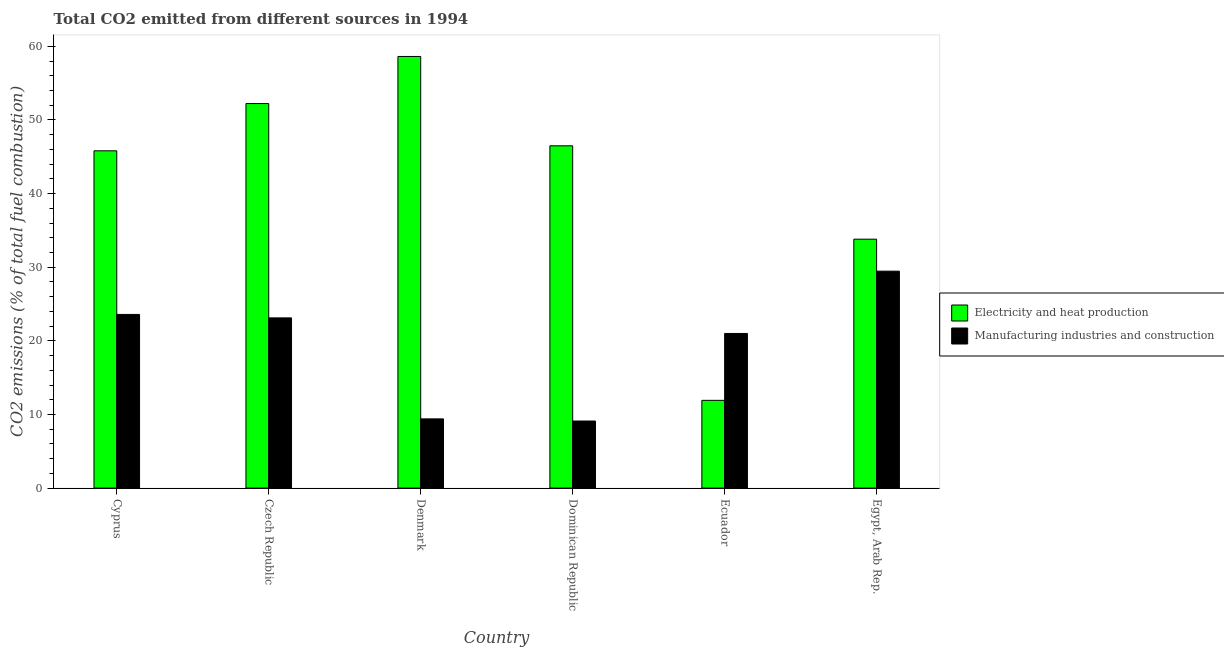How many groups of bars are there?
Your answer should be very brief. 6. Are the number of bars per tick equal to the number of legend labels?
Your response must be concise. Yes. Are the number of bars on each tick of the X-axis equal?
Your response must be concise. Yes. What is the label of the 3rd group of bars from the left?
Your answer should be very brief. Denmark. What is the co2 emissions due to electricity and heat production in Czech Republic?
Give a very brief answer. 52.23. Across all countries, what is the maximum co2 emissions due to electricity and heat production?
Offer a terse response. 58.62. Across all countries, what is the minimum co2 emissions due to electricity and heat production?
Your answer should be compact. 11.92. In which country was the co2 emissions due to electricity and heat production minimum?
Ensure brevity in your answer.  Ecuador. What is the total co2 emissions due to electricity and heat production in the graph?
Offer a terse response. 248.87. What is the difference between the co2 emissions due to electricity and heat production in Czech Republic and that in Denmark?
Your response must be concise. -6.4. What is the difference between the co2 emissions due to electricity and heat production in Egypt, Arab Rep. and the co2 emissions due to manufacturing industries in Dominican Republic?
Offer a very short reply. 24.7. What is the average co2 emissions due to manufacturing industries per country?
Offer a very short reply. 19.28. What is the difference between the co2 emissions due to manufacturing industries and co2 emissions due to electricity and heat production in Egypt, Arab Rep.?
Give a very brief answer. -4.34. In how many countries, is the co2 emissions due to electricity and heat production greater than 34 %?
Ensure brevity in your answer.  4. What is the ratio of the co2 emissions due to manufacturing industries in Cyprus to that in Denmark?
Your response must be concise. 2.51. Is the difference between the co2 emissions due to manufacturing industries in Cyprus and Ecuador greater than the difference between the co2 emissions due to electricity and heat production in Cyprus and Ecuador?
Ensure brevity in your answer.  No. What is the difference between the highest and the second highest co2 emissions due to manufacturing industries?
Your answer should be very brief. 5.87. What is the difference between the highest and the lowest co2 emissions due to manufacturing industries?
Give a very brief answer. 20.35. What does the 2nd bar from the left in Cyprus represents?
Your answer should be very brief. Manufacturing industries and construction. What does the 1st bar from the right in Egypt, Arab Rep. represents?
Offer a very short reply. Manufacturing industries and construction. How many bars are there?
Make the answer very short. 12. Are all the bars in the graph horizontal?
Your response must be concise. No. How many countries are there in the graph?
Offer a terse response. 6. Where does the legend appear in the graph?
Your answer should be very brief. Center right. What is the title of the graph?
Offer a very short reply. Total CO2 emitted from different sources in 1994. Does "Female" appear as one of the legend labels in the graph?
Provide a succinct answer. No. What is the label or title of the X-axis?
Make the answer very short. Country. What is the label or title of the Y-axis?
Your answer should be compact. CO2 emissions (% of total fuel combustion). What is the CO2 emissions (% of total fuel combustion) of Electricity and heat production in Cyprus?
Your answer should be very brief. 45.81. What is the CO2 emissions (% of total fuel combustion) of Manufacturing industries and construction in Cyprus?
Your response must be concise. 23.59. What is the CO2 emissions (% of total fuel combustion) in Electricity and heat production in Czech Republic?
Provide a succinct answer. 52.23. What is the CO2 emissions (% of total fuel combustion) of Manufacturing industries and construction in Czech Republic?
Your response must be concise. 23.12. What is the CO2 emissions (% of total fuel combustion) in Electricity and heat production in Denmark?
Ensure brevity in your answer.  58.62. What is the CO2 emissions (% of total fuel combustion) in Manufacturing industries and construction in Denmark?
Your answer should be very brief. 9.4. What is the CO2 emissions (% of total fuel combustion) in Electricity and heat production in Dominican Republic?
Offer a very short reply. 46.49. What is the CO2 emissions (% of total fuel combustion) in Manufacturing industries and construction in Dominican Republic?
Keep it short and to the point. 9.11. What is the CO2 emissions (% of total fuel combustion) of Electricity and heat production in Ecuador?
Your answer should be compact. 11.92. What is the CO2 emissions (% of total fuel combustion) of Manufacturing industries and construction in Ecuador?
Give a very brief answer. 21. What is the CO2 emissions (% of total fuel combustion) in Electricity and heat production in Egypt, Arab Rep.?
Your answer should be compact. 33.81. What is the CO2 emissions (% of total fuel combustion) of Manufacturing industries and construction in Egypt, Arab Rep.?
Your answer should be very brief. 29.46. Across all countries, what is the maximum CO2 emissions (% of total fuel combustion) in Electricity and heat production?
Keep it short and to the point. 58.62. Across all countries, what is the maximum CO2 emissions (% of total fuel combustion) in Manufacturing industries and construction?
Ensure brevity in your answer.  29.46. Across all countries, what is the minimum CO2 emissions (% of total fuel combustion) in Electricity and heat production?
Keep it short and to the point. 11.92. Across all countries, what is the minimum CO2 emissions (% of total fuel combustion) of Manufacturing industries and construction?
Provide a short and direct response. 9.11. What is the total CO2 emissions (% of total fuel combustion) in Electricity and heat production in the graph?
Provide a short and direct response. 248.87. What is the total CO2 emissions (% of total fuel combustion) in Manufacturing industries and construction in the graph?
Provide a short and direct response. 115.67. What is the difference between the CO2 emissions (% of total fuel combustion) of Electricity and heat production in Cyprus and that in Czech Republic?
Provide a short and direct response. -6.42. What is the difference between the CO2 emissions (% of total fuel combustion) in Manufacturing industries and construction in Cyprus and that in Czech Republic?
Provide a short and direct response. 0.47. What is the difference between the CO2 emissions (% of total fuel combustion) in Electricity and heat production in Cyprus and that in Denmark?
Offer a very short reply. -12.81. What is the difference between the CO2 emissions (% of total fuel combustion) in Manufacturing industries and construction in Cyprus and that in Denmark?
Your answer should be compact. 14.19. What is the difference between the CO2 emissions (% of total fuel combustion) of Electricity and heat production in Cyprus and that in Dominican Republic?
Make the answer very short. -0.68. What is the difference between the CO2 emissions (% of total fuel combustion) in Manufacturing industries and construction in Cyprus and that in Dominican Republic?
Your answer should be very brief. 14.48. What is the difference between the CO2 emissions (% of total fuel combustion) in Electricity and heat production in Cyprus and that in Ecuador?
Your response must be concise. 33.89. What is the difference between the CO2 emissions (% of total fuel combustion) in Manufacturing industries and construction in Cyprus and that in Ecuador?
Offer a terse response. 2.59. What is the difference between the CO2 emissions (% of total fuel combustion) of Electricity and heat production in Cyprus and that in Egypt, Arab Rep.?
Provide a succinct answer. 12. What is the difference between the CO2 emissions (% of total fuel combustion) in Manufacturing industries and construction in Cyprus and that in Egypt, Arab Rep.?
Give a very brief answer. -5.87. What is the difference between the CO2 emissions (% of total fuel combustion) in Electricity and heat production in Czech Republic and that in Denmark?
Provide a succinct answer. -6.4. What is the difference between the CO2 emissions (% of total fuel combustion) of Manufacturing industries and construction in Czech Republic and that in Denmark?
Offer a very short reply. 13.72. What is the difference between the CO2 emissions (% of total fuel combustion) in Electricity and heat production in Czech Republic and that in Dominican Republic?
Give a very brief answer. 5.74. What is the difference between the CO2 emissions (% of total fuel combustion) in Manufacturing industries and construction in Czech Republic and that in Dominican Republic?
Make the answer very short. 14.01. What is the difference between the CO2 emissions (% of total fuel combustion) of Electricity and heat production in Czech Republic and that in Ecuador?
Your response must be concise. 40.31. What is the difference between the CO2 emissions (% of total fuel combustion) in Manufacturing industries and construction in Czech Republic and that in Ecuador?
Your answer should be compact. 2.12. What is the difference between the CO2 emissions (% of total fuel combustion) in Electricity and heat production in Czech Republic and that in Egypt, Arab Rep.?
Provide a succinct answer. 18.42. What is the difference between the CO2 emissions (% of total fuel combustion) in Manufacturing industries and construction in Czech Republic and that in Egypt, Arab Rep.?
Your response must be concise. -6.34. What is the difference between the CO2 emissions (% of total fuel combustion) of Electricity and heat production in Denmark and that in Dominican Republic?
Your answer should be compact. 12.13. What is the difference between the CO2 emissions (% of total fuel combustion) in Manufacturing industries and construction in Denmark and that in Dominican Republic?
Keep it short and to the point. 0.29. What is the difference between the CO2 emissions (% of total fuel combustion) in Electricity and heat production in Denmark and that in Ecuador?
Ensure brevity in your answer.  46.71. What is the difference between the CO2 emissions (% of total fuel combustion) in Manufacturing industries and construction in Denmark and that in Ecuador?
Give a very brief answer. -11.6. What is the difference between the CO2 emissions (% of total fuel combustion) in Electricity and heat production in Denmark and that in Egypt, Arab Rep.?
Ensure brevity in your answer.  24.82. What is the difference between the CO2 emissions (% of total fuel combustion) of Manufacturing industries and construction in Denmark and that in Egypt, Arab Rep.?
Keep it short and to the point. -20.06. What is the difference between the CO2 emissions (% of total fuel combustion) of Electricity and heat production in Dominican Republic and that in Ecuador?
Give a very brief answer. 34.57. What is the difference between the CO2 emissions (% of total fuel combustion) of Manufacturing industries and construction in Dominican Republic and that in Ecuador?
Make the answer very short. -11.89. What is the difference between the CO2 emissions (% of total fuel combustion) of Electricity and heat production in Dominican Republic and that in Egypt, Arab Rep.?
Offer a terse response. 12.68. What is the difference between the CO2 emissions (% of total fuel combustion) of Manufacturing industries and construction in Dominican Republic and that in Egypt, Arab Rep.?
Offer a terse response. -20.35. What is the difference between the CO2 emissions (% of total fuel combustion) in Electricity and heat production in Ecuador and that in Egypt, Arab Rep.?
Provide a succinct answer. -21.89. What is the difference between the CO2 emissions (% of total fuel combustion) of Manufacturing industries and construction in Ecuador and that in Egypt, Arab Rep.?
Offer a very short reply. -8.46. What is the difference between the CO2 emissions (% of total fuel combustion) in Electricity and heat production in Cyprus and the CO2 emissions (% of total fuel combustion) in Manufacturing industries and construction in Czech Republic?
Offer a terse response. 22.69. What is the difference between the CO2 emissions (% of total fuel combustion) of Electricity and heat production in Cyprus and the CO2 emissions (% of total fuel combustion) of Manufacturing industries and construction in Denmark?
Offer a very short reply. 36.41. What is the difference between the CO2 emissions (% of total fuel combustion) of Electricity and heat production in Cyprus and the CO2 emissions (% of total fuel combustion) of Manufacturing industries and construction in Dominican Republic?
Your answer should be very brief. 36.7. What is the difference between the CO2 emissions (% of total fuel combustion) in Electricity and heat production in Cyprus and the CO2 emissions (% of total fuel combustion) in Manufacturing industries and construction in Ecuador?
Offer a very short reply. 24.81. What is the difference between the CO2 emissions (% of total fuel combustion) of Electricity and heat production in Cyprus and the CO2 emissions (% of total fuel combustion) of Manufacturing industries and construction in Egypt, Arab Rep.?
Your answer should be very brief. 16.35. What is the difference between the CO2 emissions (% of total fuel combustion) in Electricity and heat production in Czech Republic and the CO2 emissions (% of total fuel combustion) in Manufacturing industries and construction in Denmark?
Give a very brief answer. 42.83. What is the difference between the CO2 emissions (% of total fuel combustion) of Electricity and heat production in Czech Republic and the CO2 emissions (% of total fuel combustion) of Manufacturing industries and construction in Dominican Republic?
Offer a very short reply. 43.12. What is the difference between the CO2 emissions (% of total fuel combustion) in Electricity and heat production in Czech Republic and the CO2 emissions (% of total fuel combustion) in Manufacturing industries and construction in Ecuador?
Your answer should be compact. 31.23. What is the difference between the CO2 emissions (% of total fuel combustion) in Electricity and heat production in Czech Republic and the CO2 emissions (% of total fuel combustion) in Manufacturing industries and construction in Egypt, Arab Rep.?
Your response must be concise. 22.76. What is the difference between the CO2 emissions (% of total fuel combustion) of Electricity and heat production in Denmark and the CO2 emissions (% of total fuel combustion) of Manufacturing industries and construction in Dominican Republic?
Make the answer very short. 49.52. What is the difference between the CO2 emissions (% of total fuel combustion) in Electricity and heat production in Denmark and the CO2 emissions (% of total fuel combustion) in Manufacturing industries and construction in Ecuador?
Your answer should be compact. 37.62. What is the difference between the CO2 emissions (% of total fuel combustion) of Electricity and heat production in Denmark and the CO2 emissions (% of total fuel combustion) of Manufacturing industries and construction in Egypt, Arab Rep.?
Ensure brevity in your answer.  29.16. What is the difference between the CO2 emissions (% of total fuel combustion) of Electricity and heat production in Dominican Republic and the CO2 emissions (% of total fuel combustion) of Manufacturing industries and construction in Ecuador?
Your answer should be very brief. 25.49. What is the difference between the CO2 emissions (% of total fuel combustion) of Electricity and heat production in Dominican Republic and the CO2 emissions (% of total fuel combustion) of Manufacturing industries and construction in Egypt, Arab Rep.?
Make the answer very short. 17.03. What is the difference between the CO2 emissions (% of total fuel combustion) of Electricity and heat production in Ecuador and the CO2 emissions (% of total fuel combustion) of Manufacturing industries and construction in Egypt, Arab Rep.?
Make the answer very short. -17.55. What is the average CO2 emissions (% of total fuel combustion) in Electricity and heat production per country?
Ensure brevity in your answer.  41.48. What is the average CO2 emissions (% of total fuel combustion) in Manufacturing industries and construction per country?
Offer a terse response. 19.28. What is the difference between the CO2 emissions (% of total fuel combustion) of Electricity and heat production and CO2 emissions (% of total fuel combustion) of Manufacturing industries and construction in Cyprus?
Your response must be concise. 22.22. What is the difference between the CO2 emissions (% of total fuel combustion) of Electricity and heat production and CO2 emissions (% of total fuel combustion) of Manufacturing industries and construction in Czech Republic?
Provide a succinct answer. 29.11. What is the difference between the CO2 emissions (% of total fuel combustion) of Electricity and heat production and CO2 emissions (% of total fuel combustion) of Manufacturing industries and construction in Denmark?
Offer a terse response. 49.22. What is the difference between the CO2 emissions (% of total fuel combustion) in Electricity and heat production and CO2 emissions (% of total fuel combustion) in Manufacturing industries and construction in Dominican Republic?
Keep it short and to the point. 37.38. What is the difference between the CO2 emissions (% of total fuel combustion) of Electricity and heat production and CO2 emissions (% of total fuel combustion) of Manufacturing industries and construction in Ecuador?
Your answer should be compact. -9.08. What is the difference between the CO2 emissions (% of total fuel combustion) in Electricity and heat production and CO2 emissions (% of total fuel combustion) in Manufacturing industries and construction in Egypt, Arab Rep.?
Provide a short and direct response. 4.34. What is the ratio of the CO2 emissions (% of total fuel combustion) in Electricity and heat production in Cyprus to that in Czech Republic?
Make the answer very short. 0.88. What is the ratio of the CO2 emissions (% of total fuel combustion) of Manufacturing industries and construction in Cyprus to that in Czech Republic?
Your response must be concise. 1.02. What is the ratio of the CO2 emissions (% of total fuel combustion) in Electricity and heat production in Cyprus to that in Denmark?
Provide a short and direct response. 0.78. What is the ratio of the CO2 emissions (% of total fuel combustion) in Manufacturing industries and construction in Cyprus to that in Denmark?
Provide a short and direct response. 2.51. What is the ratio of the CO2 emissions (% of total fuel combustion) in Electricity and heat production in Cyprus to that in Dominican Republic?
Ensure brevity in your answer.  0.99. What is the ratio of the CO2 emissions (% of total fuel combustion) of Manufacturing industries and construction in Cyprus to that in Dominican Republic?
Offer a very short reply. 2.59. What is the ratio of the CO2 emissions (% of total fuel combustion) of Electricity and heat production in Cyprus to that in Ecuador?
Provide a short and direct response. 3.84. What is the ratio of the CO2 emissions (% of total fuel combustion) in Manufacturing industries and construction in Cyprus to that in Ecuador?
Keep it short and to the point. 1.12. What is the ratio of the CO2 emissions (% of total fuel combustion) in Electricity and heat production in Cyprus to that in Egypt, Arab Rep.?
Provide a short and direct response. 1.35. What is the ratio of the CO2 emissions (% of total fuel combustion) of Manufacturing industries and construction in Cyprus to that in Egypt, Arab Rep.?
Provide a short and direct response. 0.8. What is the ratio of the CO2 emissions (% of total fuel combustion) in Electricity and heat production in Czech Republic to that in Denmark?
Offer a terse response. 0.89. What is the ratio of the CO2 emissions (% of total fuel combustion) of Manufacturing industries and construction in Czech Republic to that in Denmark?
Provide a short and direct response. 2.46. What is the ratio of the CO2 emissions (% of total fuel combustion) in Electricity and heat production in Czech Republic to that in Dominican Republic?
Ensure brevity in your answer.  1.12. What is the ratio of the CO2 emissions (% of total fuel combustion) of Manufacturing industries and construction in Czech Republic to that in Dominican Republic?
Ensure brevity in your answer.  2.54. What is the ratio of the CO2 emissions (% of total fuel combustion) of Electricity and heat production in Czech Republic to that in Ecuador?
Offer a terse response. 4.38. What is the ratio of the CO2 emissions (% of total fuel combustion) of Manufacturing industries and construction in Czech Republic to that in Ecuador?
Your answer should be very brief. 1.1. What is the ratio of the CO2 emissions (% of total fuel combustion) in Electricity and heat production in Czech Republic to that in Egypt, Arab Rep.?
Ensure brevity in your answer.  1.54. What is the ratio of the CO2 emissions (% of total fuel combustion) in Manufacturing industries and construction in Czech Republic to that in Egypt, Arab Rep.?
Offer a very short reply. 0.78. What is the ratio of the CO2 emissions (% of total fuel combustion) in Electricity and heat production in Denmark to that in Dominican Republic?
Your answer should be very brief. 1.26. What is the ratio of the CO2 emissions (% of total fuel combustion) in Manufacturing industries and construction in Denmark to that in Dominican Republic?
Offer a terse response. 1.03. What is the ratio of the CO2 emissions (% of total fuel combustion) in Electricity and heat production in Denmark to that in Ecuador?
Your answer should be compact. 4.92. What is the ratio of the CO2 emissions (% of total fuel combustion) of Manufacturing industries and construction in Denmark to that in Ecuador?
Your response must be concise. 0.45. What is the ratio of the CO2 emissions (% of total fuel combustion) of Electricity and heat production in Denmark to that in Egypt, Arab Rep.?
Your answer should be very brief. 1.73. What is the ratio of the CO2 emissions (% of total fuel combustion) in Manufacturing industries and construction in Denmark to that in Egypt, Arab Rep.?
Ensure brevity in your answer.  0.32. What is the ratio of the CO2 emissions (% of total fuel combustion) in Electricity and heat production in Dominican Republic to that in Ecuador?
Provide a short and direct response. 3.9. What is the ratio of the CO2 emissions (% of total fuel combustion) in Manufacturing industries and construction in Dominican Republic to that in Ecuador?
Offer a very short reply. 0.43. What is the ratio of the CO2 emissions (% of total fuel combustion) of Electricity and heat production in Dominican Republic to that in Egypt, Arab Rep.?
Make the answer very short. 1.38. What is the ratio of the CO2 emissions (% of total fuel combustion) of Manufacturing industries and construction in Dominican Republic to that in Egypt, Arab Rep.?
Your response must be concise. 0.31. What is the ratio of the CO2 emissions (% of total fuel combustion) of Electricity and heat production in Ecuador to that in Egypt, Arab Rep.?
Give a very brief answer. 0.35. What is the ratio of the CO2 emissions (% of total fuel combustion) in Manufacturing industries and construction in Ecuador to that in Egypt, Arab Rep.?
Make the answer very short. 0.71. What is the difference between the highest and the second highest CO2 emissions (% of total fuel combustion) of Electricity and heat production?
Provide a succinct answer. 6.4. What is the difference between the highest and the second highest CO2 emissions (% of total fuel combustion) in Manufacturing industries and construction?
Make the answer very short. 5.87. What is the difference between the highest and the lowest CO2 emissions (% of total fuel combustion) of Electricity and heat production?
Your answer should be compact. 46.71. What is the difference between the highest and the lowest CO2 emissions (% of total fuel combustion) in Manufacturing industries and construction?
Offer a very short reply. 20.35. 